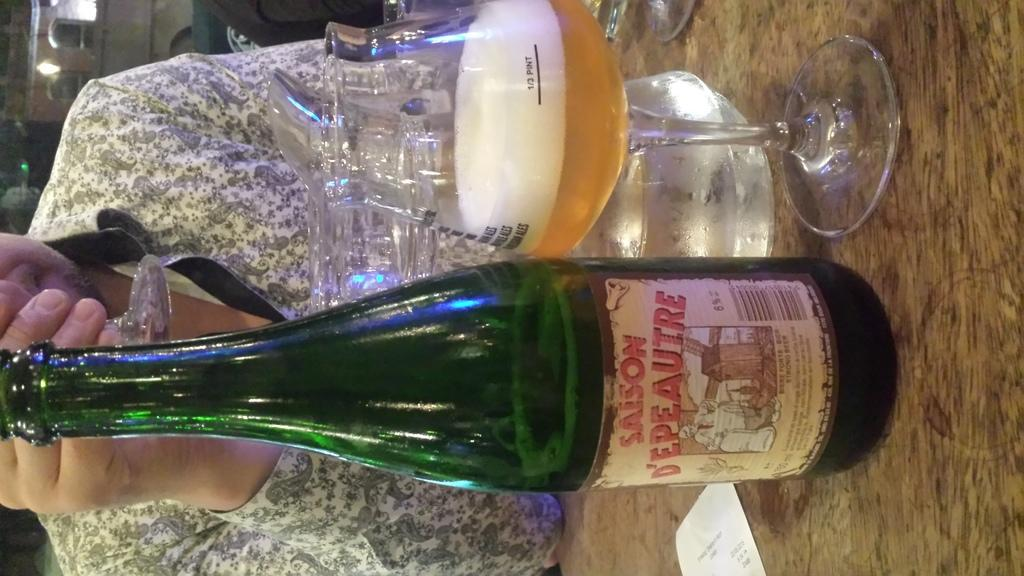Provide a one-sentence caption for the provided image. the word saison that is on a bottle. 